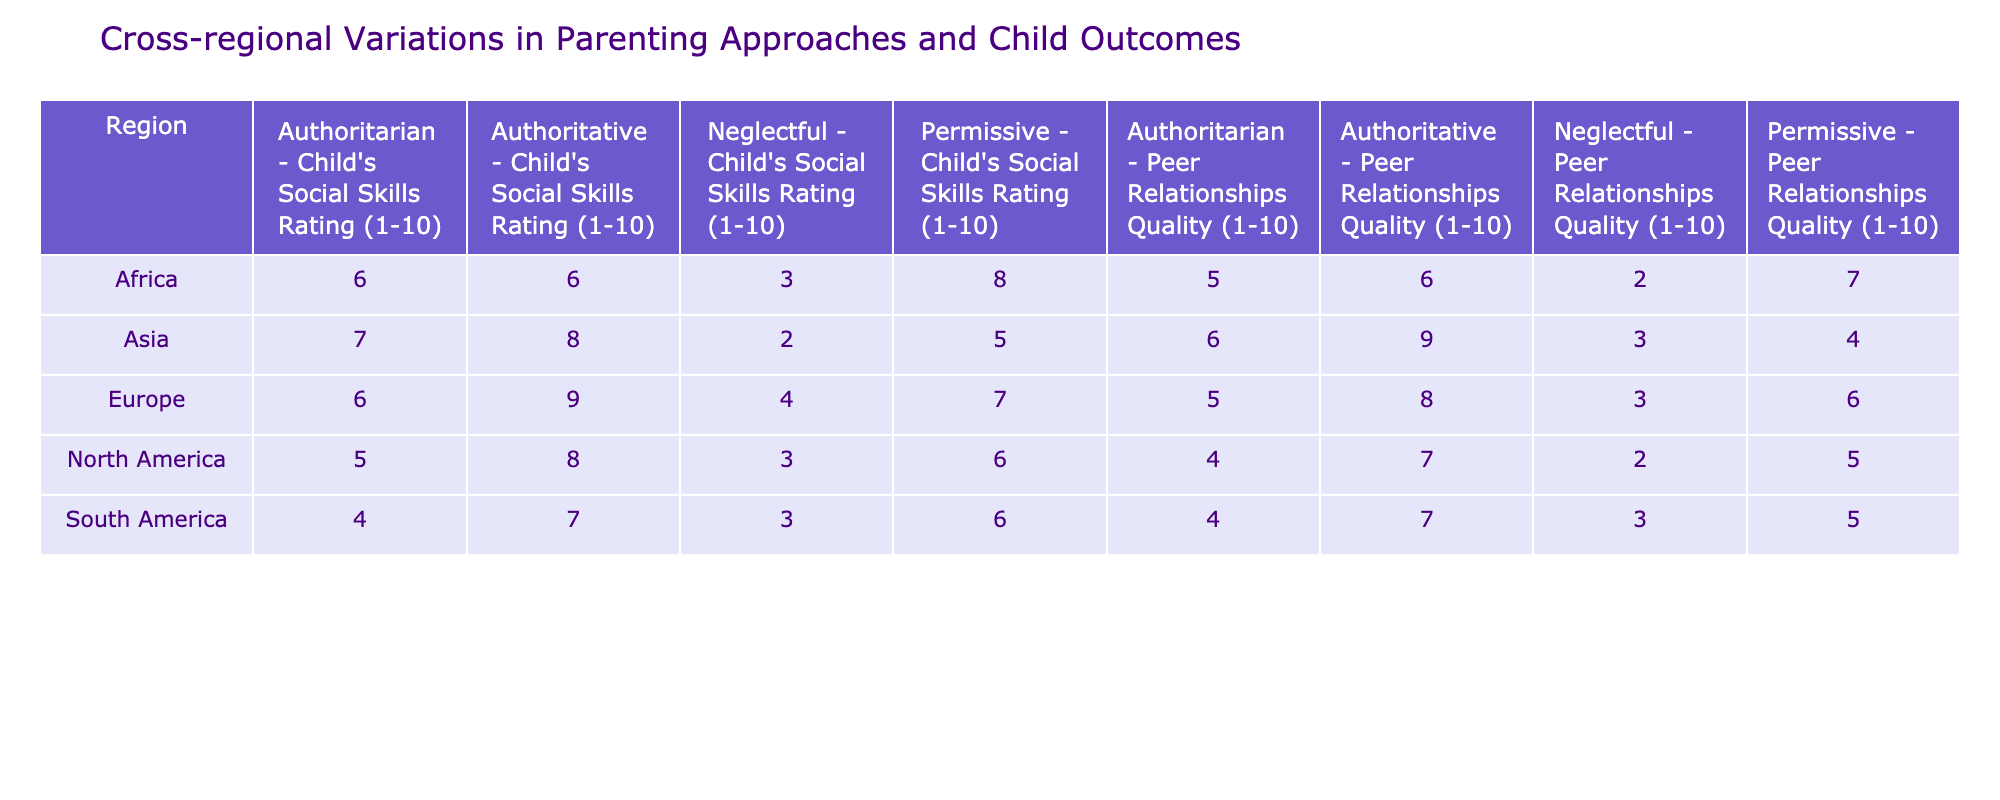What is the highest Child's Social Skills Rating in North America? In the North America region, the highest rating among the parenting styles is for the Authoritative style, which is rated at 8.
Answer: 8 What is the average Peer Relationships Quality for the Authoritative parenting style across all regions? To find the average for the Authoritative style, I will gather the Peer Relationships Quality ratings: North America 7, Europe 8, Asia 9, Africa 6, and South America 7. The total is 7 + 8 + 9 + 6 + 7 = 37, and there are 5 regions, so the average is 37 / 5 = 7.4.
Answer: 7.4 Is the Neglectful parenting style associated with higher Child's Social Skills Rating in Asia compared to Africa? In Asia, the Neglectful parenting style has a rating of 2, while in Africa it has a higher rating of 3. Therefore, the statement is false.
Answer: No Which region has the lowest average Child's Social Skills Rating across all parenting styles? The Child's Social Skills Ratings for each region are North America (5.5), Europe (6.5), Asia (5.5), Africa (5.75), and South America (5). South America has the lowest average at 5.
Answer: South America What is the difference in average Peer Relationships Quality between Permissive parenting style and Authoritarian parenting style in Europe? For Europe, the average Peer Relationships Quality for Permissive is 6 and for Authoritarian it is 5. The difference is 6 - 5 = 1.
Answer: 1 Is it true that all regions have a higher Child's Social Skills Rating for Authoritative compared to Authoritarian? The Child's Social Skills Ratings for Authoritative and Authoritarian are compared: North America (8 vs 5), Europe (9 vs 6), Asia (8 vs 7), Africa (6 vs 6), and South America (7 vs 4). In Africa, both ratings are equal, making the statement false.
Answer: No Which region has the highest rating for Peer Relationships Quality under the Permissive parenting style? For the Permissive parenting style, the ratings are: North America 5, Europe 6, Asia 4, Africa 7, South America 5. Africa has the highest rating at 7.
Answer: Africa What is the average Child's Social Skills Rating for the Neglectful parenting style across all regions? The Child's Social Skills Ratings for the Neglectful parenting style are: North America 3, Europe 4, Asia 2, Africa 3, South America 3. The total is 3 + 4 + 2 + 3 + 3 = 15; the average is 15 / 5 = 3.
Answer: 3 Are Child's Social Skills Ratings higher for Authoritative compared to Permissive in every region? Comparing ratings: North America (8 vs 6), Europe (9 vs 7), Asia (8 vs 5), Africa (6 vs 8), South America (7 vs 6). In Africa, Permissive is higher, so the statement is false.
Answer: No 